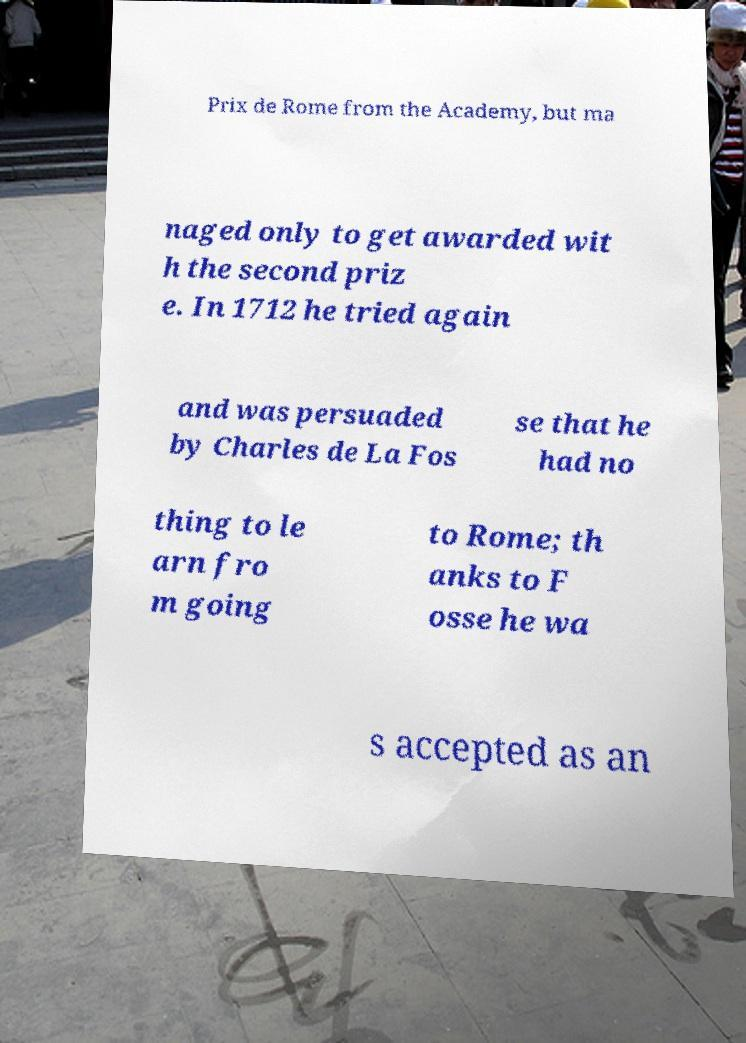Can you accurately transcribe the text from the provided image for me? Prix de Rome from the Academy, but ma naged only to get awarded wit h the second priz e. In 1712 he tried again and was persuaded by Charles de La Fos se that he had no thing to le arn fro m going to Rome; th anks to F osse he wa s accepted as an 